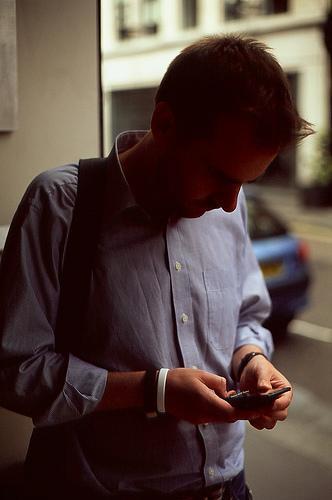How many pockets are on his shirt?
Give a very brief answer. 1. 